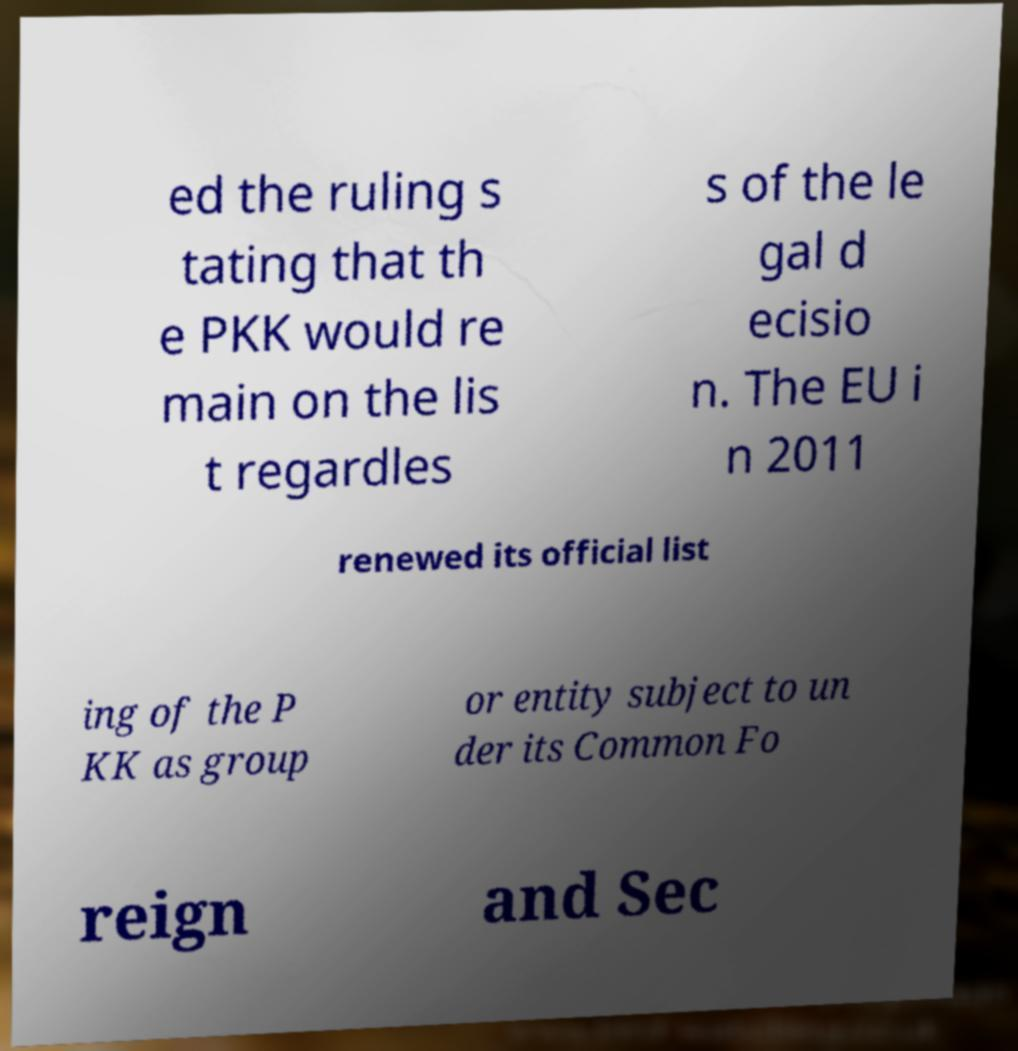Can you read and provide the text displayed in the image?This photo seems to have some interesting text. Can you extract and type it out for me? ed the ruling s tating that th e PKK would re main on the lis t regardles s of the le gal d ecisio n. The EU i n 2011 renewed its official list ing of the P KK as group or entity subject to un der its Common Fo reign and Sec 